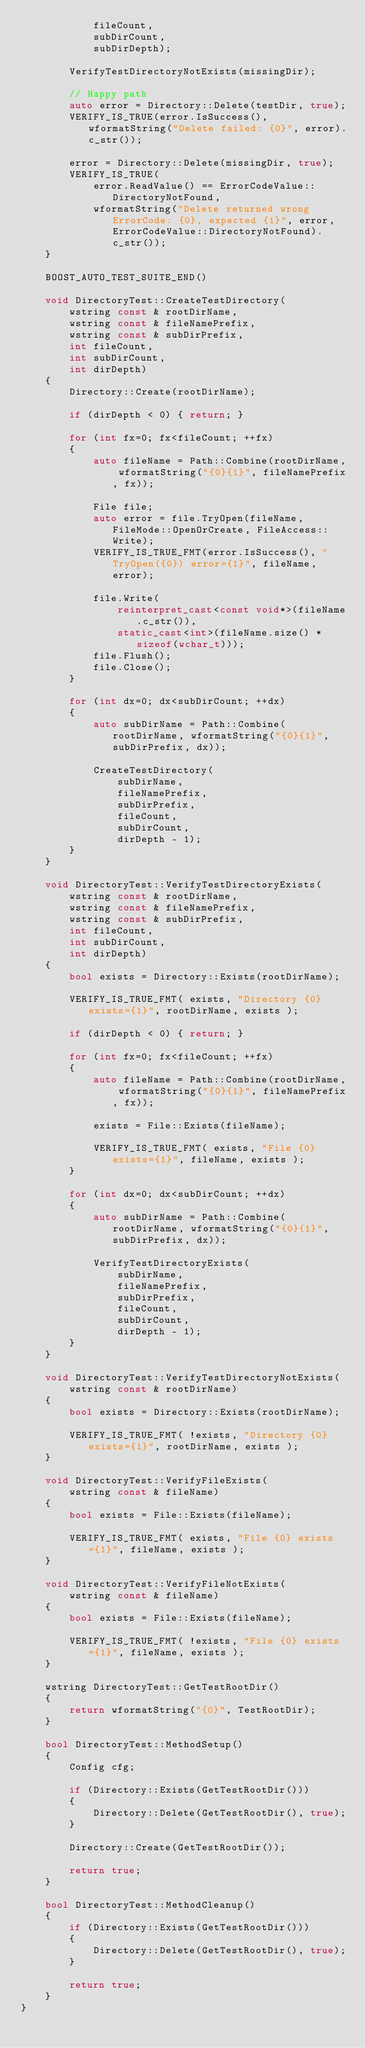Convert code to text. <code><loc_0><loc_0><loc_500><loc_500><_C++_>            fileCount,
            subDirCount,
            subDirDepth);

        VerifyTestDirectoryNotExists(missingDir);

        // Happy path
        auto error = Directory::Delete(testDir, true);
        VERIFY_IS_TRUE(error.IsSuccess(), wformatString("Delete failed: {0}", error).c_str());

        error = Directory::Delete(missingDir, true);
        VERIFY_IS_TRUE(
            error.ReadValue() == ErrorCodeValue::DirectoryNotFound, 
            wformatString("Delete returned wrong ErrorCode: {0}, expected {1}", error, ErrorCodeValue::DirectoryNotFound).c_str());
    }

    BOOST_AUTO_TEST_SUITE_END()

    void DirectoryTest::CreateTestDirectory(
        wstring const & rootDirName,
        wstring const & fileNamePrefix,
        wstring const & subDirPrefix,
        int fileCount,
        int subDirCount,
        int dirDepth)
    {
        Directory::Create(rootDirName);

        if (dirDepth < 0) { return; }

        for (int fx=0; fx<fileCount; ++fx)
        {
            auto fileName = Path::Combine(rootDirName, wformatString("{0}{1}", fileNamePrefix, fx));

            File file;
            auto error = file.TryOpen(fileName, FileMode::OpenOrCreate, FileAccess::Write);
            VERIFY_IS_TRUE_FMT(error.IsSuccess(), "TryOpen({0}) error={1}", fileName, error);

            file.Write(
                reinterpret_cast<const void*>(fileName.c_str()), 
                static_cast<int>(fileName.size() * sizeof(wchar_t)));
            file.Flush();
            file.Close();
        }

        for (int dx=0; dx<subDirCount; ++dx)
        {
            auto subDirName = Path::Combine(rootDirName, wformatString("{0}{1}", subDirPrefix, dx));

            CreateTestDirectory(
                subDirName,
                fileNamePrefix,
                subDirPrefix,
                fileCount,
                subDirCount,
                dirDepth - 1);
        }
    }
    
    void DirectoryTest::VerifyTestDirectoryExists(
        wstring const & rootDirName,
        wstring const & fileNamePrefix,
        wstring const & subDirPrefix,
        int fileCount,
        int subDirCount,
        int dirDepth)
    {
        bool exists = Directory::Exists(rootDirName);

        VERIFY_IS_TRUE_FMT( exists, "Directory {0} exists={1}", rootDirName, exists );

        if (dirDepth < 0) { return; }

        for (int fx=0; fx<fileCount; ++fx)
        {
            auto fileName = Path::Combine(rootDirName, wformatString("{0}{1}", fileNamePrefix, fx));

            exists = File::Exists(fileName);

            VERIFY_IS_TRUE_FMT( exists, "File {0} exists={1}", fileName, exists );
        }

        for (int dx=0; dx<subDirCount; ++dx)
        {
            auto subDirName = Path::Combine(rootDirName, wformatString("{0}{1}", subDirPrefix, dx));

            VerifyTestDirectoryExists(
                subDirName,
                fileNamePrefix,
                subDirPrefix,
                fileCount,
                subDirCount,
                dirDepth - 1);
        }
    }

    void DirectoryTest::VerifyTestDirectoryNotExists(
        wstring const & rootDirName)
    {
        bool exists = Directory::Exists(rootDirName);

        VERIFY_IS_TRUE_FMT( !exists, "Directory {0} exists={1}", rootDirName, exists );
    }

    void DirectoryTest::VerifyFileExists(
        wstring const & fileName)
    {
        bool exists = File::Exists(fileName);

        VERIFY_IS_TRUE_FMT( exists, "File {0} exists={1}", fileName, exists );
    }

    void DirectoryTest::VerifyFileNotExists(
        wstring const & fileName)
    {
        bool exists = File::Exists(fileName);

        VERIFY_IS_TRUE_FMT( !exists, "File {0} exists={1}", fileName, exists );
    }

    wstring DirectoryTest::GetTestRootDir()
    {
        return wformatString("{0}", TestRootDir);
    }

    bool DirectoryTest::MethodSetup()
    {
        Config cfg;

        if (Directory::Exists(GetTestRootDir()))
        {
            Directory::Delete(GetTestRootDir(), true);
        }

        Directory::Create(GetTestRootDir());

        return true;
    }

    bool DirectoryTest::MethodCleanup()
    {
        if (Directory::Exists(GetTestRootDir()))
        {
            Directory::Delete(GetTestRootDir(), true);
        }

        return true;
    }
}
</code> 